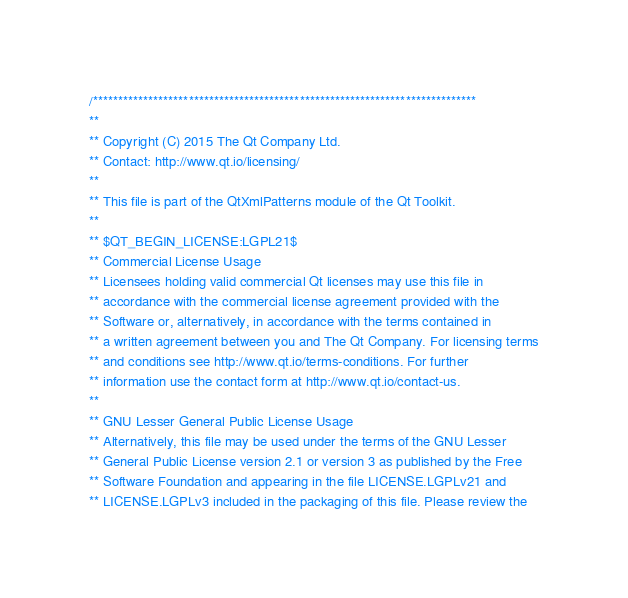Convert code to text. <code><loc_0><loc_0><loc_500><loc_500><_C++_>/****************************************************************************
**
** Copyright (C) 2015 The Qt Company Ltd.
** Contact: http://www.qt.io/licensing/
**
** This file is part of the QtXmlPatterns module of the Qt Toolkit.
**
** $QT_BEGIN_LICENSE:LGPL21$
** Commercial License Usage
** Licensees holding valid commercial Qt licenses may use this file in
** accordance with the commercial license agreement provided with the
** Software or, alternatively, in accordance with the terms contained in
** a written agreement between you and The Qt Company. For licensing terms
** and conditions see http://www.qt.io/terms-conditions. For further
** information use the contact form at http://www.qt.io/contact-us.
**
** GNU Lesser General Public License Usage
** Alternatively, this file may be used under the terms of the GNU Lesser
** General Public License version 2.1 or version 3 as published by the Free
** Software Foundation and appearing in the file LICENSE.LGPLv21 and
** LICENSE.LGPLv3 included in the packaging of this file. Please review the</code> 